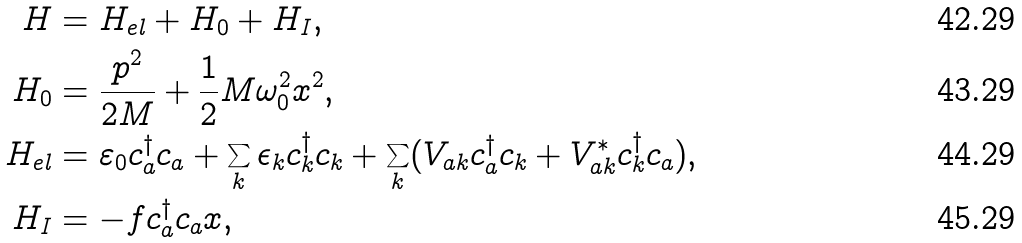Convert formula to latex. <formula><loc_0><loc_0><loc_500><loc_500>H & = H _ { e l } + H _ { 0 } + H _ { I } , \\ H _ { 0 } & = \frac { p ^ { 2 } } { 2 M } + \frac { 1 } { 2 } M \omega _ { 0 } ^ { 2 } x ^ { 2 } , \\ H _ { e l } & = \varepsilon _ { 0 } c _ { a } ^ { \dag } c _ { a } + \sum _ { k } \epsilon _ { k } c _ { k } ^ { \dag } c _ { k } + \sum _ { k } ( V _ { a k } c _ { a } ^ { \dag } c _ { k } + V _ { a k } ^ { * } c _ { k } ^ { \dag } c _ { a } ) , \\ H _ { I } & = - f c _ { a } ^ { \dag } c _ { a } x ,</formula> 